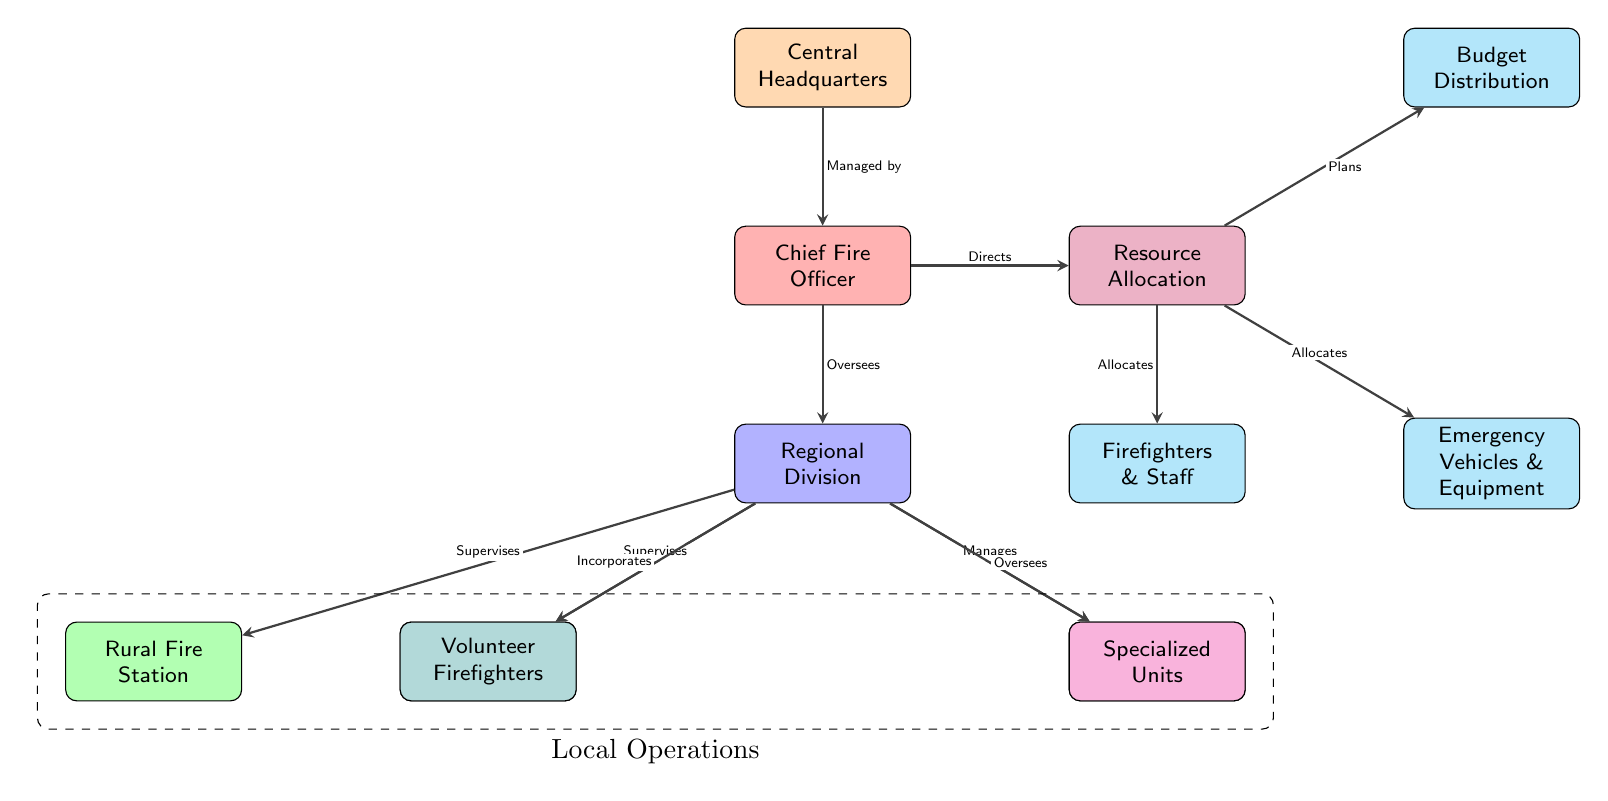What is the top node in the diagram? The diagram's top node represents the Central Headquarters, as it is the first and highest level in the organizational chart.
Answer: Central Headquarters How many types of fire stations are represented in the diagram? The diagram shows two types of fire stations: Urban Fire Station and Rural Fire Station. These can be identified as they are positioned below the Regional Division node.
Answer: 2 What does the Chief Fire Officer oversee? The Chief Fire Officer oversees the Regional Division, as indicated by the directed edge connecting them in the diagram.
Answer: Regional Division Which node is responsible for planning budget distribution? The Resource Allocation node is responsible for planning budget distribution, as shown by the connection between Resource Allocation and Budget Distribution in the diagram.
Answer: Resource Allocation What is the relationship between the Regional Division and Volunteer Firefighters? The Regional Division incorporates the Volunteer Firefighters, which is indicated by the directed edge connecting these nodes in the diagram.
Answer: Incorporates What are the three main areas connected to the Resource Allocation node? The three main areas connected to the Resource Allocation node are Firefighters & Staff, Emergency Vehicles & Equipment, and Budget Distribution, as these nodes branch out from Resource Allocation.
Answer: Firefighters & Staff, Emergency Vehicles & Equipment, Budget Distribution How does the Chief Fire Officer direct operations related to resources? The Chief Fire Officer directs operations related to resources through the Resource Allocation node, which represents their directive role in managing available resources.
Answer: Directs What local operations are included under the dashed box in the diagram? The dashed box labeled "Local Operations" includes the Urban Fire Station, Rural Fire Station, Volunteer Firefighters, and Specialized Units, as these nodes fall within the grouped area.
Answer: Urban Fire Station, Rural Fire Station, Volunteer Firefighters, Specialized Units Which units does the Regional Division oversee? The Regional Division oversees the Specialized Units, as indicated by the connection in the diagram. This reflects its supervisory role in managing specialized teams.
Answer: Specialized Units 